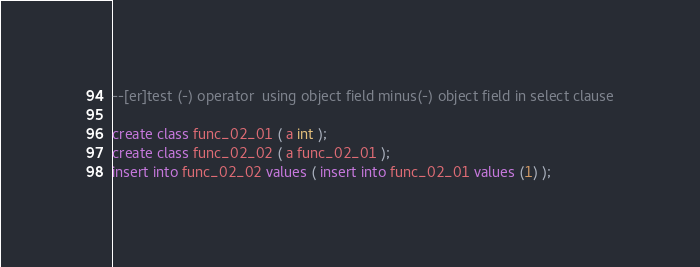Convert code to text. <code><loc_0><loc_0><loc_500><loc_500><_SQL_>--[er]test (-) operator  using object field minus(-) object field in select clause

create class func_02_01 ( a int );
create class func_02_02 ( a func_02_01 );
insert into func_02_02 values ( insert into func_02_01 values (1) );
</code> 